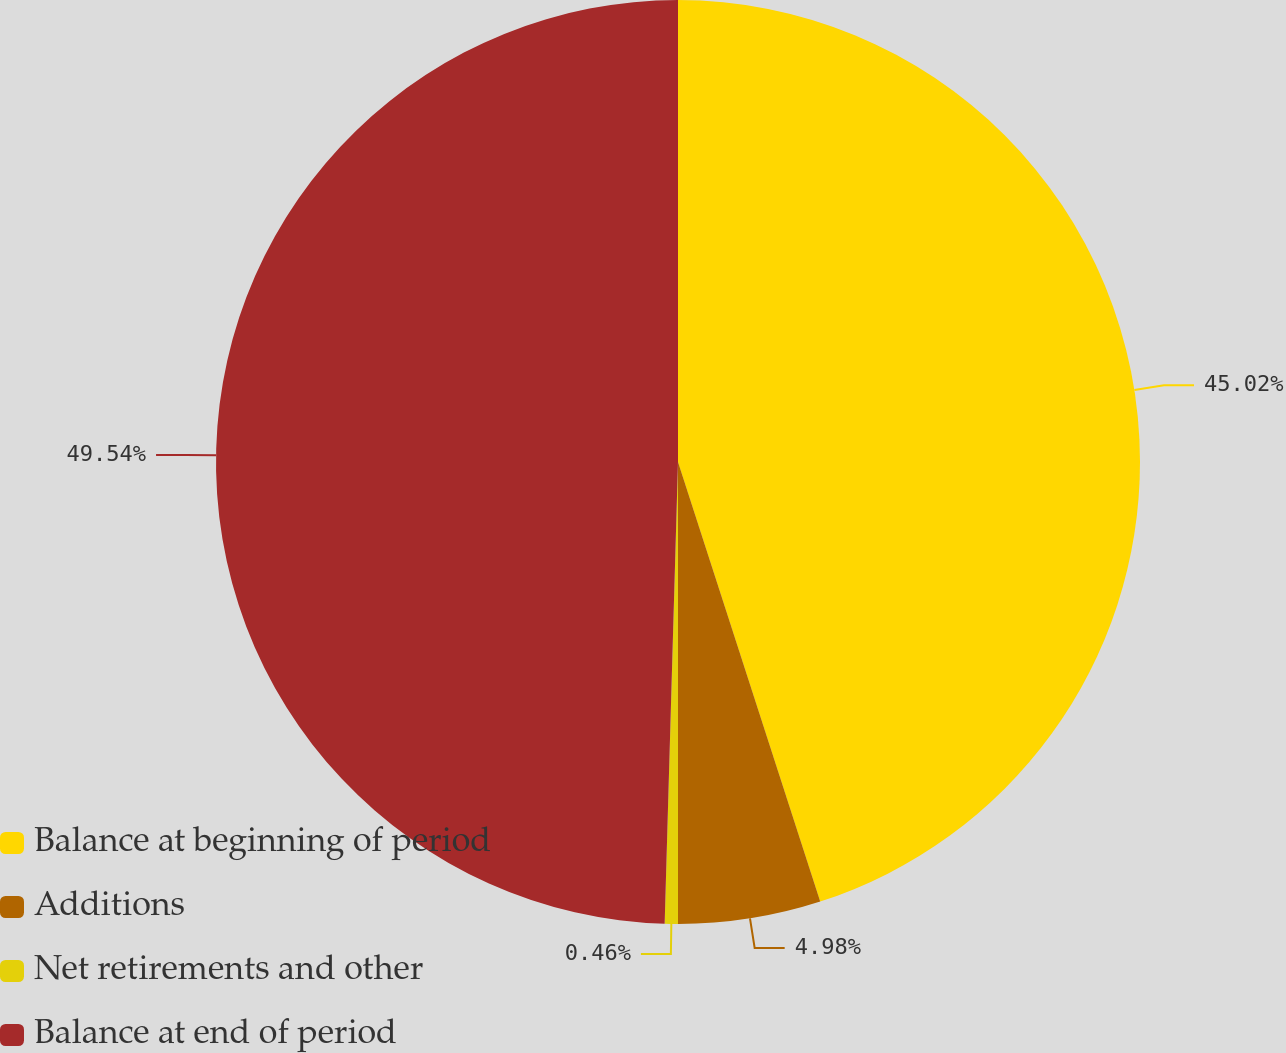<chart> <loc_0><loc_0><loc_500><loc_500><pie_chart><fcel>Balance at beginning of period<fcel>Additions<fcel>Net retirements and other<fcel>Balance at end of period<nl><fcel>45.02%<fcel>4.98%<fcel>0.46%<fcel>49.54%<nl></chart> 